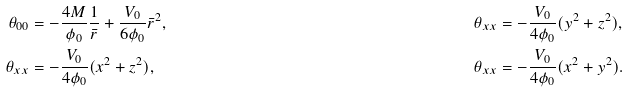Convert formula to latex. <formula><loc_0><loc_0><loc_500><loc_500>\theta _ { 0 0 } & = - \frac { 4 M } { \phi _ { 0 } } \frac { 1 } { \bar { r } } + \frac { V _ { 0 } } { 6 \phi _ { 0 } } \bar { r } ^ { 2 } , & \theta _ { x x } & = - \frac { V _ { 0 } } { 4 \phi _ { 0 } } ( y ^ { 2 } + z ^ { 2 } ) , \\ \theta _ { x x } & = - \frac { V _ { 0 } } { 4 \phi _ { 0 } } ( x ^ { 2 } + z ^ { 2 } ) , & \theta _ { x x } & = - \frac { V _ { 0 } } { 4 \phi _ { 0 } } ( x ^ { 2 } + y ^ { 2 } ) .</formula> 